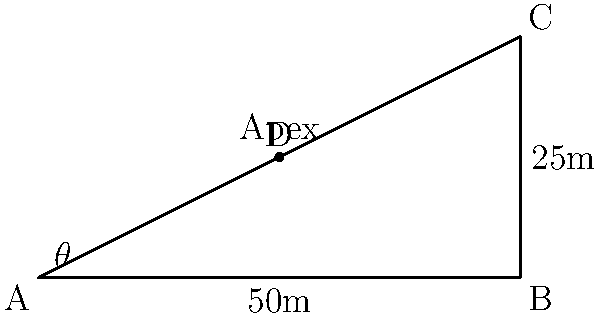In a high-speed corner of a Formula 1 circuit, the ideal racing line forms a triangle ABC with the following dimensions: AB = 50m (track width), BC = 25m (corner exit). The apex of the corner is at point D on line AC. If the angle θ at point A is the entry angle for the ideal racing line, calculate θ to the nearest degree. To solve this problem, we'll use the tangent function and the properties of right-angled triangles. Let's break it down step-by-step:

1) First, we need to identify the right-angled triangle that contains angle θ. This is triangle ABD.

2) In this triangle:
   - The adjacent side to angle θ is AB, which is 50m.
   - The opposite side to angle θ is the height of point D.

3) To find the height of point D, we can use the similarity of triangles ABC and ABD:
   - The ratio of AD:AB is the same as BD:BC
   - AD:50 = 5:25 (as BD is half of BC)
   - AD = 10m

4) Now we know that D is at (10,5) if we consider A as (0,0) and B as (50,0).

5) In triangle ABD:
   - Adjacent = 50m
   - Opposite = 5m

6) We can now use the tangent function:

   $$\tan(\theta) = \frac{\text{opposite}}{\text{adjacent}} = \frac{5}{50} = 0.1$$

7) To find θ, we need to use the inverse tangent (arctangent) function:

   $$\theta = \arctan(0.1)$$

8) Using a calculator or mathematical software:

   $$\theta \approx 5.71°$$

9) Rounding to the nearest degree:

   $$\theta \approx 6°$$
Answer: 6° 